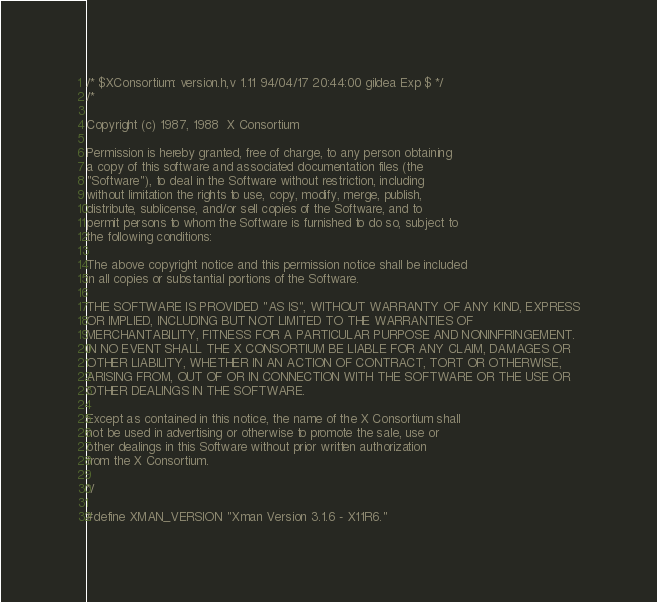<code> <loc_0><loc_0><loc_500><loc_500><_C_>/* $XConsortium: version.h,v 1.11 94/04/17 20:44:00 gildea Exp $ */
/*

Copyright (c) 1987, 1988  X Consortium

Permission is hereby granted, free of charge, to any person obtaining
a copy of this software and associated documentation files (the
"Software"), to deal in the Software without restriction, including
without limitation the rights to use, copy, modify, merge, publish,
distribute, sublicense, and/or sell copies of the Software, and to
permit persons to whom the Software is furnished to do so, subject to
the following conditions:

The above copyright notice and this permission notice shall be included
in all copies or substantial portions of the Software.

THE SOFTWARE IS PROVIDED "AS IS", WITHOUT WARRANTY OF ANY KIND, EXPRESS
OR IMPLIED, INCLUDING BUT NOT LIMITED TO THE WARRANTIES OF
MERCHANTABILITY, FITNESS FOR A PARTICULAR PURPOSE AND NONINFRINGEMENT.
IN NO EVENT SHALL THE X CONSORTIUM BE LIABLE FOR ANY CLAIM, DAMAGES OR
OTHER LIABILITY, WHETHER IN AN ACTION OF CONTRACT, TORT OR OTHERWISE,
ARISING FROM, OUT OF OR IN CONNECTION WITH THE SOFTWARE OR THE USE OR
OTHER DEALINGS IN THE SOFTWARE.

Except as contained in this notice, the name of the X Consortium shall
not be used in advertising or otherwise to promote the sale, use or
other dealings in this Software without prior written authorization
from the X Consortium.

*/

#define XMAN_VERSION "Xman Version 3.1.6 - X11R6."
</code> 